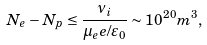<formula> <loc_0><loc_0><loc_500><loc_500>N _ { e } - N _ { p } \leq \frac { \nu _ { i } } { \mu _ { e } e / \varepsilon _ { 0 } } \sim 1 0 ^ { 2 0 } m ^ { 3 } ,</formula> 